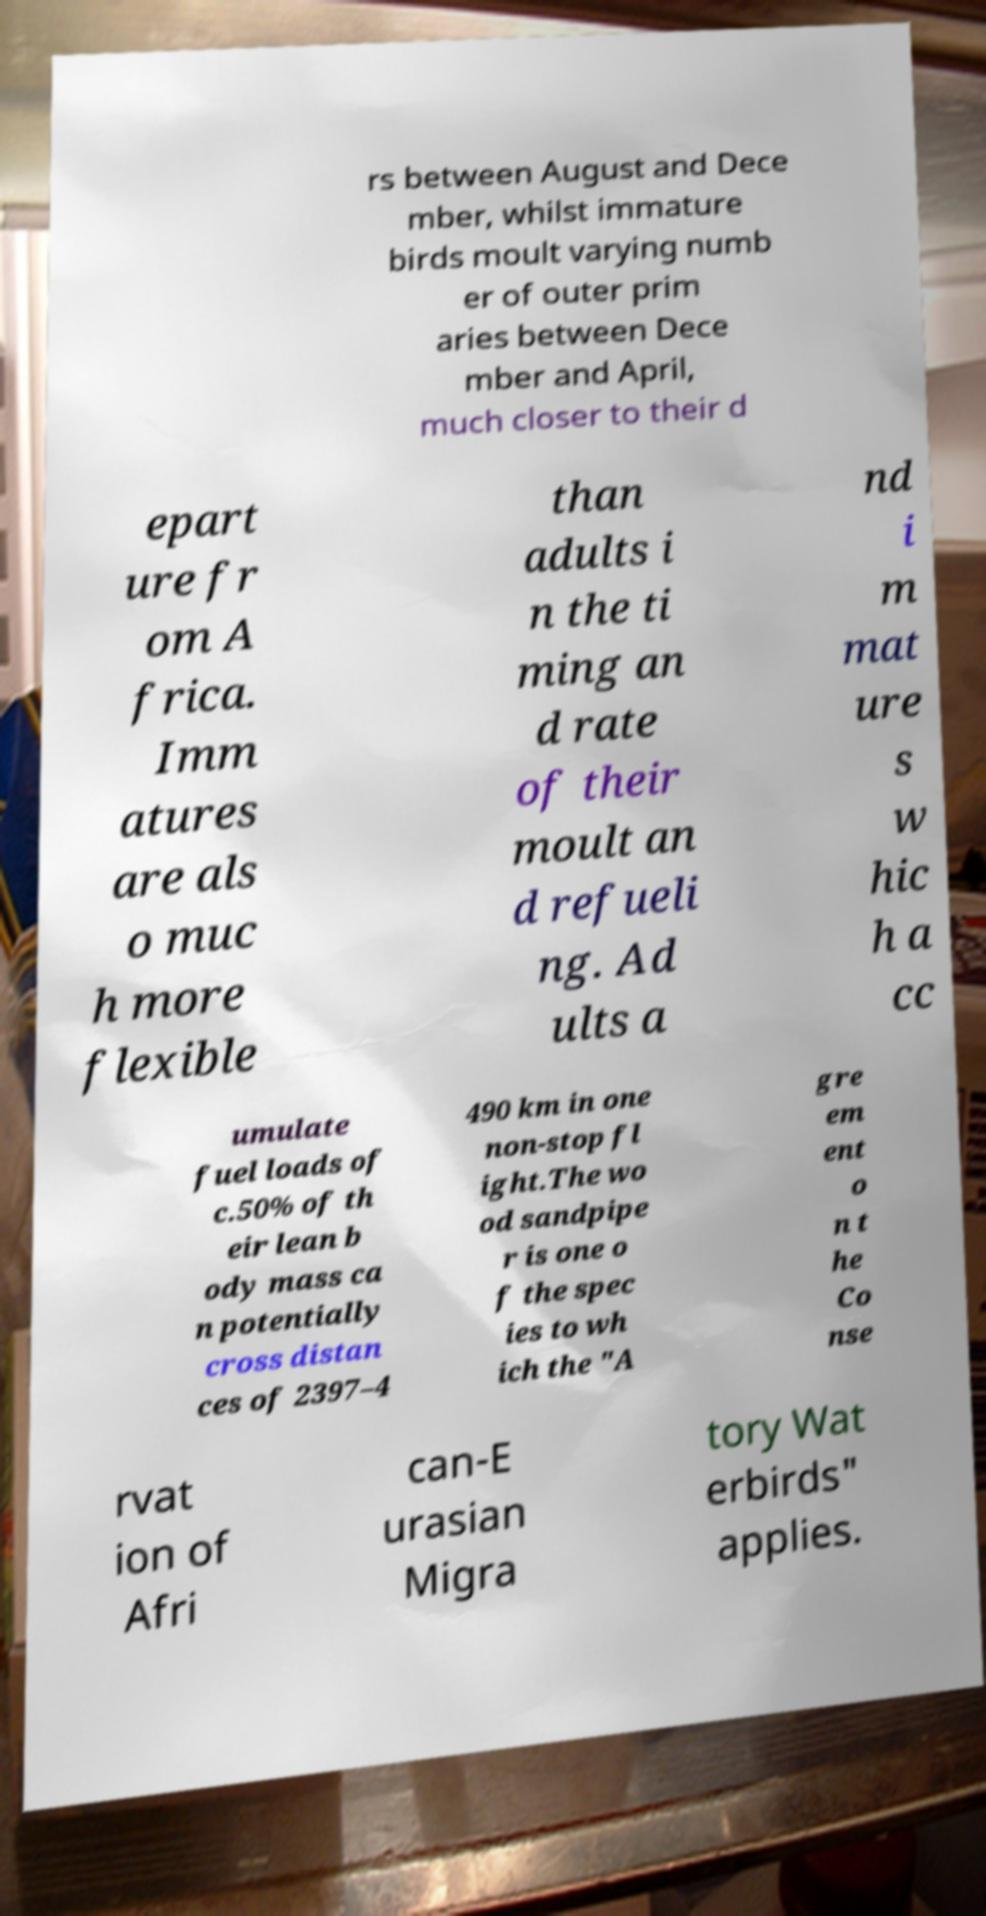There's text embedded in this image that I need extracted. Can you transcribe it verbatim? rs between August and Dece mber, whilst immature birds moult varying numb er of outer prim aries between Dece mber and April, much closer to their d epart ure fr om A frica. Imm atures are als o muc h more flexible than adults i n the ti ming an d rate of their moult an d refueli ng. Ad ults a nd i m mat ure s w hic h a cc umulate fuel loads of c.50% of th eir lean b ody mass ca n potentially cross distan ces of 2397–4 490 km in one non-stop fl ight.The wo od sandpipe r is one o f the spec ies to wh ich the "A gre em ent o n t he Co nse rvat ion of Afri can-E urasian Migra tory Wat erbirds" applies. 